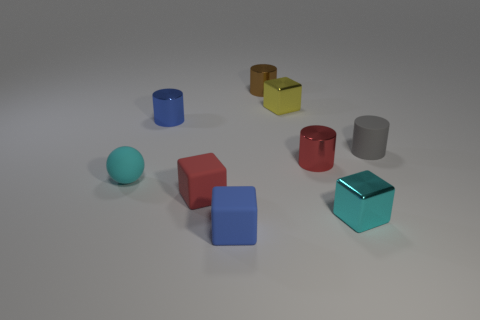Subtract 1 cylinders. How many cylinders are left? 3 Subtract all cubes. How many objects are left? 5 Subtract all tiny cyan metal blocks. Subtract all cyan spheres. How many objects are left? 7 Add 2 rubber blocks. How many rubber blocks are left? 4 Add 9 small blue shiny cylinders. How many small blue shiny cylinders exist? 10 Subtract 0 purple blocks. How many objects are left? 9 